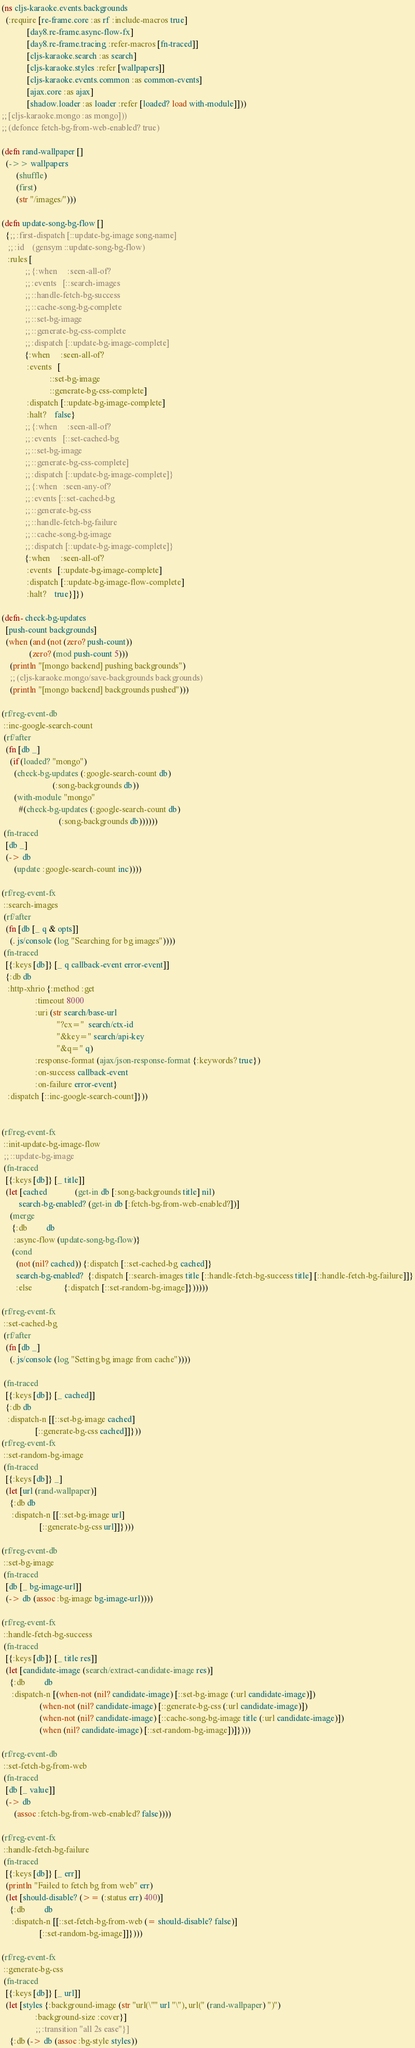<code> <loc_0><loc_0><loc_500><loc_500><_Clojure_>(ns cljs-karaoke.events.backgrounds
  (:require [re-frame.core :as rf :include-macros true]
            [day8.re-frame.async-flow-fx]
            [day8.re-frame.tracing :refer-macros [fn-traced]]
            [cljs-karaoke.search :as search]
            [cljs-karaoke.styles :refer [wallpapers]]
            [cljs-karaoke.events.common :as common-events]
            [ajax.core :as ajax]
            [shadow.loader :as loader :refer [loaded? load with-module]]))
;; [cljs-karaoke.mongo :as mongo]))
;; (defonce fetch-bg-from-web-enabled? true)

(defn rand-wallpaper []
  (->> wallpapers
       (shuffle)
       (first)
       (str "/images/")))

(defn update-song-bg-flow []
  {;; :first-dispatch [::update-bg-image song-name]
   ;; :id    (gensym ::update-song-bg-flow)
   :rules [
           ;; {:when     :seen-all-of?
           ;; :events   [::search-images
           ;; ::handle-fetch-bg-success
           ;; ::cache-song-bg-complete
           ;; ::set-bg-image
           ;; ::generate-bg-css-complete
           ;; :dispatch [::update-bg-image-complete]
           {:when     :seen-all-of?
            :events   [
                       ::set-bg-image
                       ::generate-bg-css-complete]
            :dispatch [::update-bg-image-complete]
            :halt?    false}
           ;; {:when     :seen-all-of?
           ;; :events   [::set-cached-bg
           ;; ::set-bg-image
           ;; ::generate-bg-css-complete]
           ;; :dispatch [::update-bg-image-complete]}
           ;; {:when   :seen-any-of?
           ;; :events [::set-cached-bg
           ;; ::generate-bg-css
           ;; ::handle-fetch-bg-failure
           ;; ::cache-song-bg-image
           ;; :dispatch [::update-bg-image-complete]}
           {:when     :seen-all-of?
            :events   [::update-bg-image-complete]
            :dispatch [::update-bg-image-flow-complete]
            :halt?    true}]})

(defn- check-bg-updates
  [push-count backgrounds]
  (when (and (not (zero? push-count))
             (zero? (mod push-count 5)))
    (println "[mongo backend] pushing backgrounds")
    ;; (cljs-karaoke.mongo/save-backgrounds backgrounds)
    (println "[mongo backend] backgrounds pushed")))

(rf/reg-event-db
 ::inc-google-search-count
 (rf/after
  (fn [db _]
    (if (loaded? "mongo")
      (check-bg-updates (:google-search-count db)
                        (:song-backgrounds db))
      (with-module "mongo"
        #(check-bg-updates (:google-search-count db)
                           (:song-backgrounds db))))))
 (fn-traced
  [db _]
  (-> db
      (update :google-search-count inc))))

(rf/reg-event-fx
 ::search-images
 (rf/after
  (fn [db [_ q & opts]]
    (. js/console (log "Searching for bg images"))))
 (fn-traced
  [{:keys [db]} [_ q callback-event error-event]]
  {:db db
   :http-xhrio {:method :get
                :timeout 8000
                :uri (str search/base-url
                          "?cx="  search/ctx-id
                          "&key=" search/api-key
                          "&q=" q)
                :response-format (ajax/json-response-format {:keywords? true})
                :on-success callback-event
                :on-failure error-event}
   :dispatch [::inc-google-search-count]}))


(rf/reg-event-fx
 ::init-update-bg-image-flow
 ;; ::update-bg-image
 (fn-traced
  [{:keys [db]} [_ title]]
  (let [cached             (get-in db [:song-backgrounds title] nil)
        search-bg-enabled? (get-in db [:fetch-bg-from-web-enabled?])]
    (merge
     {:db         db
      :async-flow (update-song-bg-flow)}
     (cond
       (not (nil? cached)) {:dispatch [::set-cached-bg cached]}
       search-bg-enabled?  {:dispatch [::search-images title [::handle-fetch-bg-success title] [::handle-fetch-bg-failure]]}
       :else               {:dispatch [::set-random-bg-image]})))))

(rf/reg-event-fx
 ::set-cached-bg
 (rf/after
  (fn [db _]
    (. js/console (log "Setting bg image from cache"))))

 (fn-traced
  [{:keys [db]} [_ cached]]
  {:db db
   :dispatch-n [[::set-bg-image cached]
                [::generate-bg-css cached]]}))
(rf/reg-event-fx
 ::set-random-bg-image
 (fn-traced
  [{:keys [db]} _]
  (let [url (rand-wallpaper)]
    {:db db
     :dispatch-n [[::set-bg-image url]
                  [::generate-bg-css url]]})))

(rf/reg-event-db
 ::set-bg-image
 (fn-traced
  [db [_ bg-image-url]]
  (-> db (assoc :bg-image bg-image-url))))

(rf/reg-event-fx
 ::handle-fetch-bg-success
 (fn-traced
  [{:keys [db]} [_ title res]]
  (let [candidate-image (search/extract-candidate-image res)]
    {:db         db
     :dispatch-n [(when-not (nil? candidate-image) [::set-bg-image (:url candidate-image)])
                  (when-not (nil? candidate-image) [::generate-bg-css (:url candidate-image)])
                  (when-not (nil? candidate-image) [::cache-song-bg-image title (:url candidate-image)])
                  (when (nil? candidate-image) [::set-random-bg-image])]})))

(rf/reg-event-db
 ::set-fetch-bg-from-web
 (fn-traced
  [db [_ value]]
  (-> db
      (assoc :fetch-bg-from-web-enabled? false))))

(rf/reg-event-fx
 ::handle-fetch-bg-failure
 (fn-traced
  [{:keys [db]} [_ err]]
  (println "Failed to fetch bg from web" err)
  (let [should-disable? (>= (:status err) 400)]
    {:db         db
     :dispatch-n [[::set-fetch-bg-from-web (= should-disable? false)]
                  [::set-random-bg-image]]})))

(rf/reg-event-fx
 ::generate-bg-css
 (fn-traced
  [{:keys [db]} [_ url]]
  (let [styles {:background-image (str "url(\"" url "\"), url(" (rand-wallpaper) ")")
                :background-size :cover}]
                ;; :transition "all 2s ease"}]
    {:db (-> db (assoc :bg-style styles))</code> 